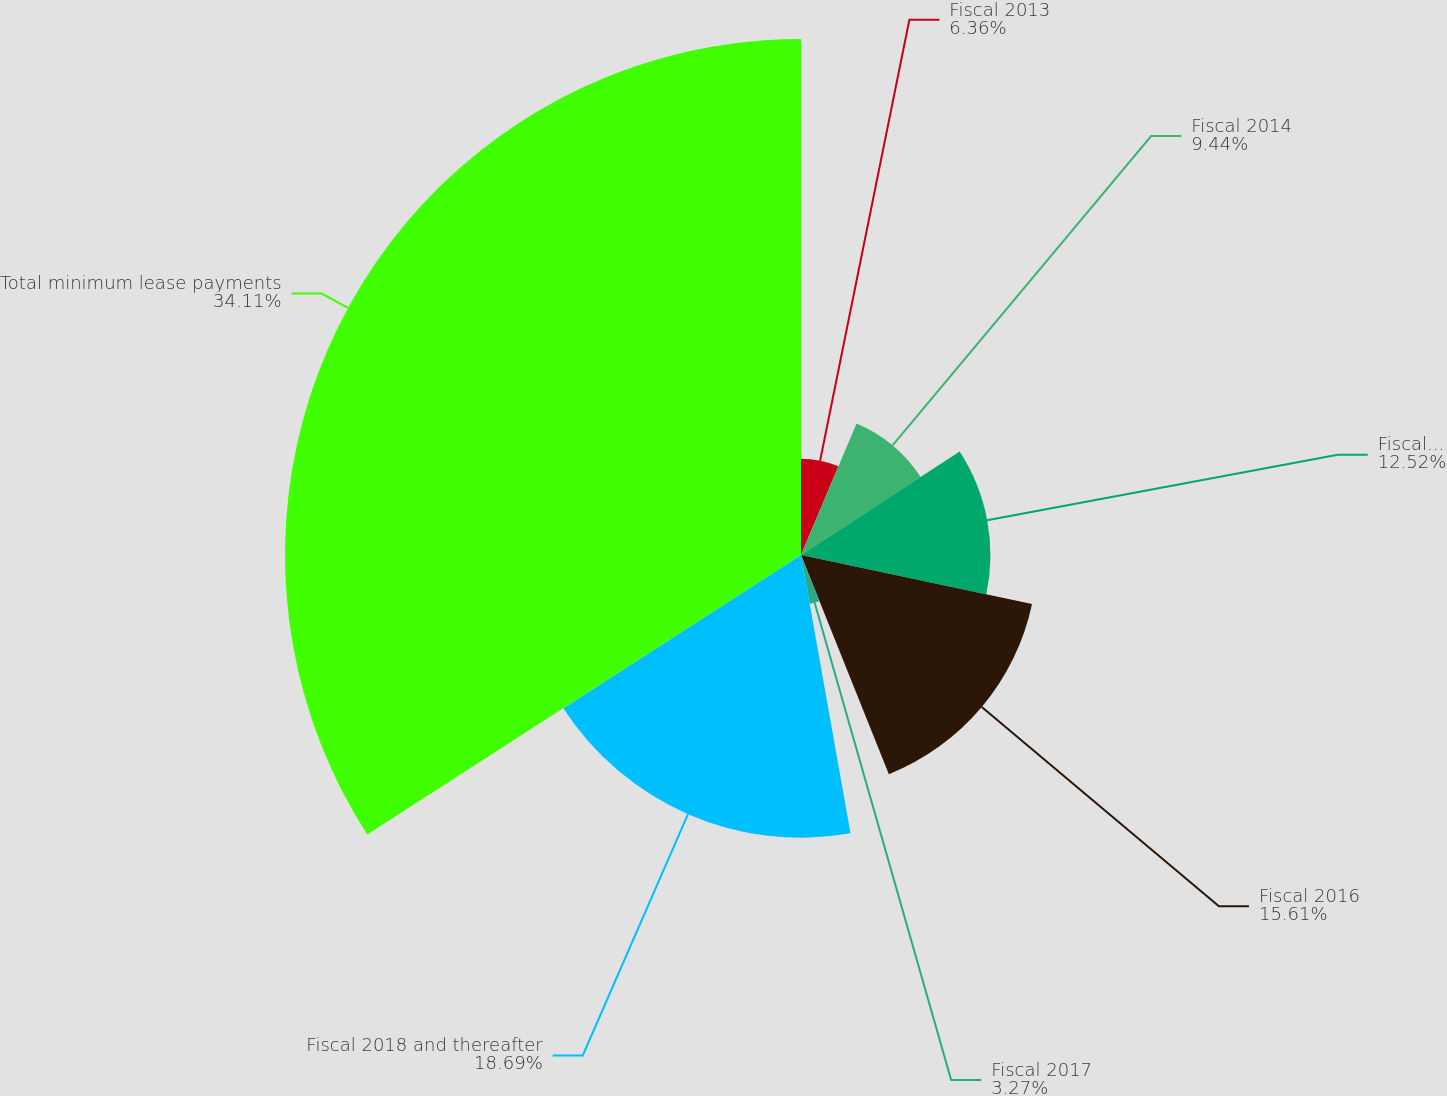Convert chart to OTSL. <chart><loc_0><loc_0><loc_500><loc_500><pie_chart><fcel>Fiscal 2013<fcel>Fiscal 2014<fcel>Fiscal 2015<fcel>Fiscal 2016<fcel>Fiscal 2017<fcel>Fiscal 2018 and thereafter<fcel>Total minimum lease payments<nl><fcel>6.36%<fcel>9.44%<fcel>12.52%<fcel>15.61%<fcel>3.27%<fcel>18.69%<fcel>34.11%<nl></chart> 